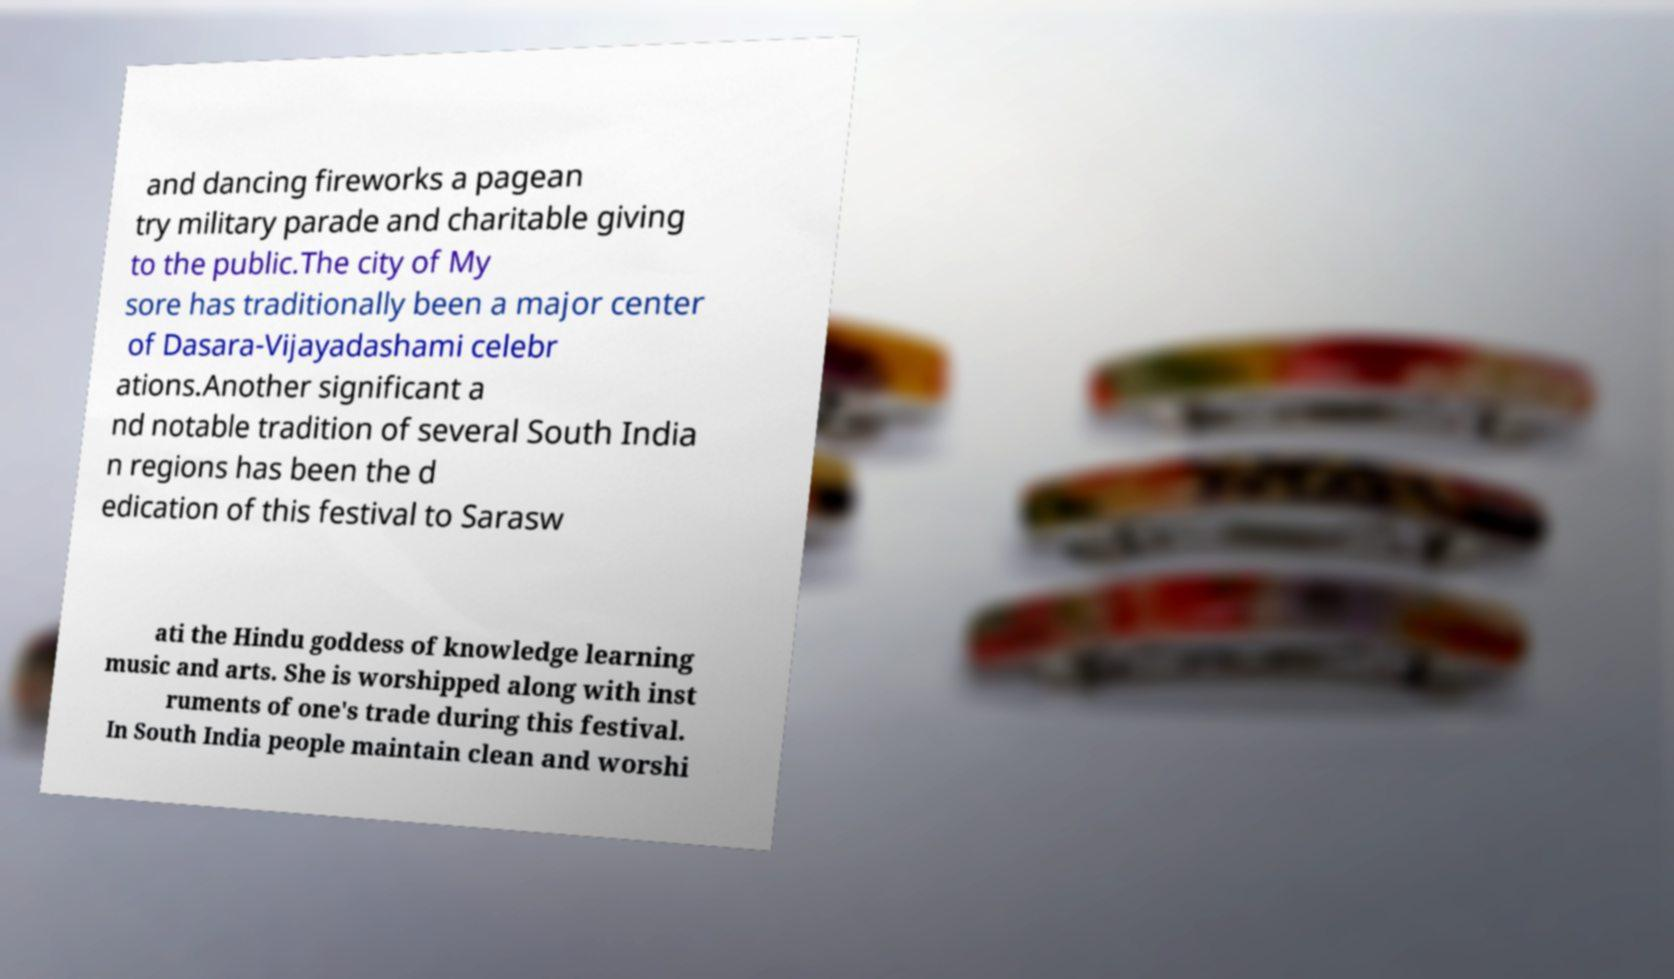Can you accurately transcribe the text from the provided image for me? and dancing fireworks a pagean try military parade and charitable giving to the public.The city of My sore has traditionally been a major center of Dasara-Vijayadashami celebr ations.Another significant a nd notable tradition of several South India n regions has been the d edication of this festival to Sarasw ati the Hindu goddess of knowledge learning music and arts. She is worshipped along with inst ruments of one's trade during this festival. In South India people maintain clean and worshi 